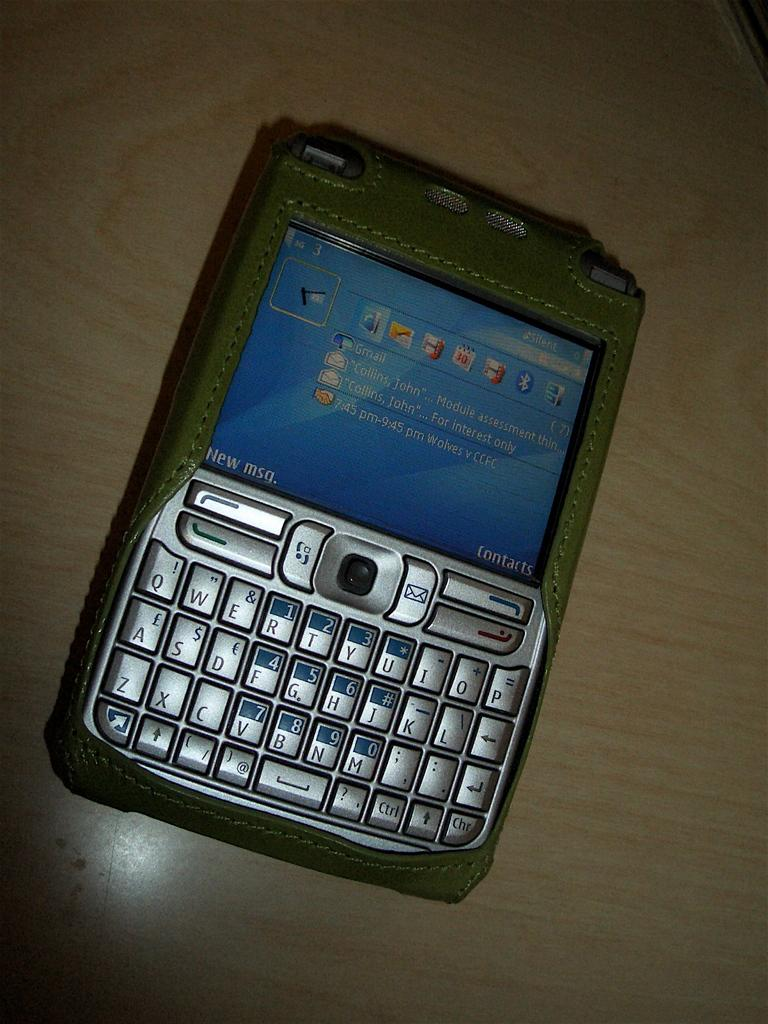<image>
Describe the image concisely. A cell phone has Contacts and New msg. messages on the screen. 